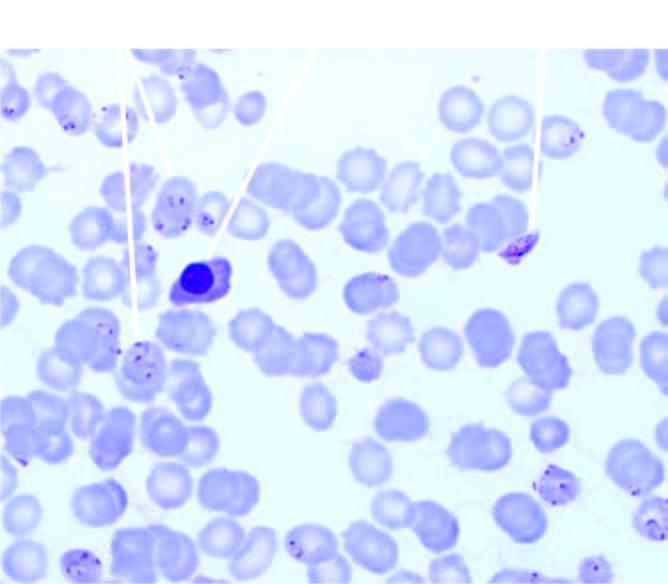does thickness and intensity of colour of arrow on left side of figure show a normoblast?
Answer the question using a single word or phrase. No 